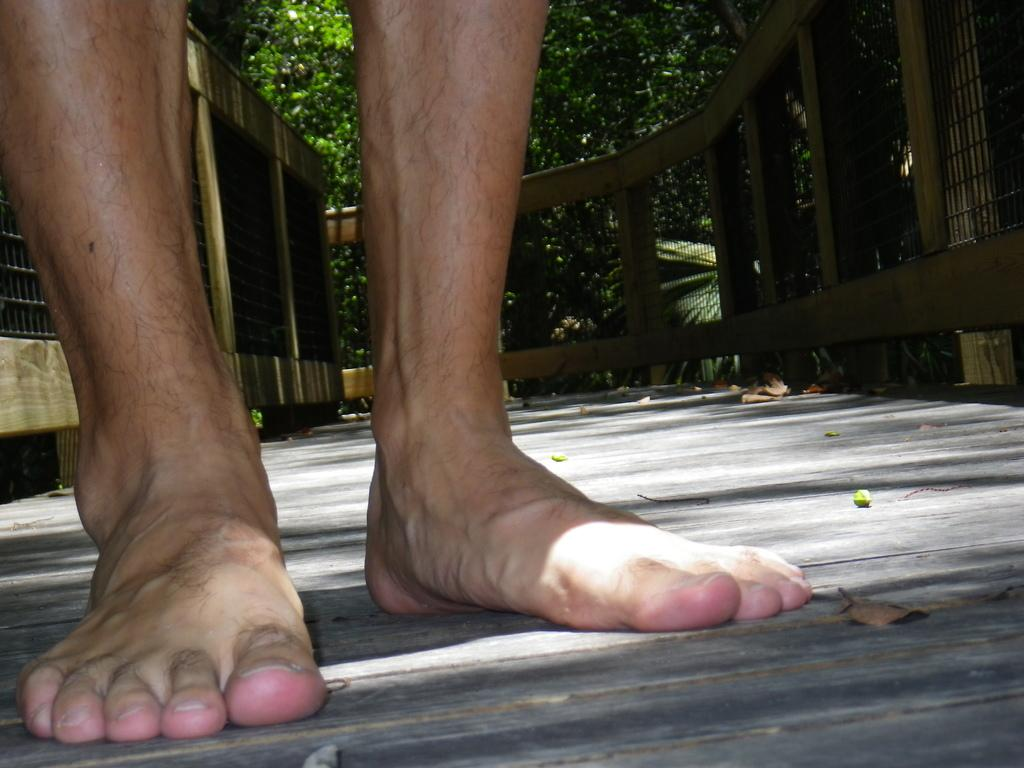What part of a person can be seen in the image? There are legs of a person visible in the image. What can be seen in the background of the image? There is a fence and trees in the background of the image. Can you see a crown on the person's head in the image? There is no crown visible on the person's head in the image. Is there any dust visible in the image? There is no mention of dust in the provided facts, and therefore it cannot be determined if dust is visible in the image. 